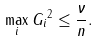<formula> <loc_0><loc_0><loc_500><loc_500>\max _ { i } \| G _ { i } \| ^ { 2 } \leq \frac { \nu } { n } .</formula> 